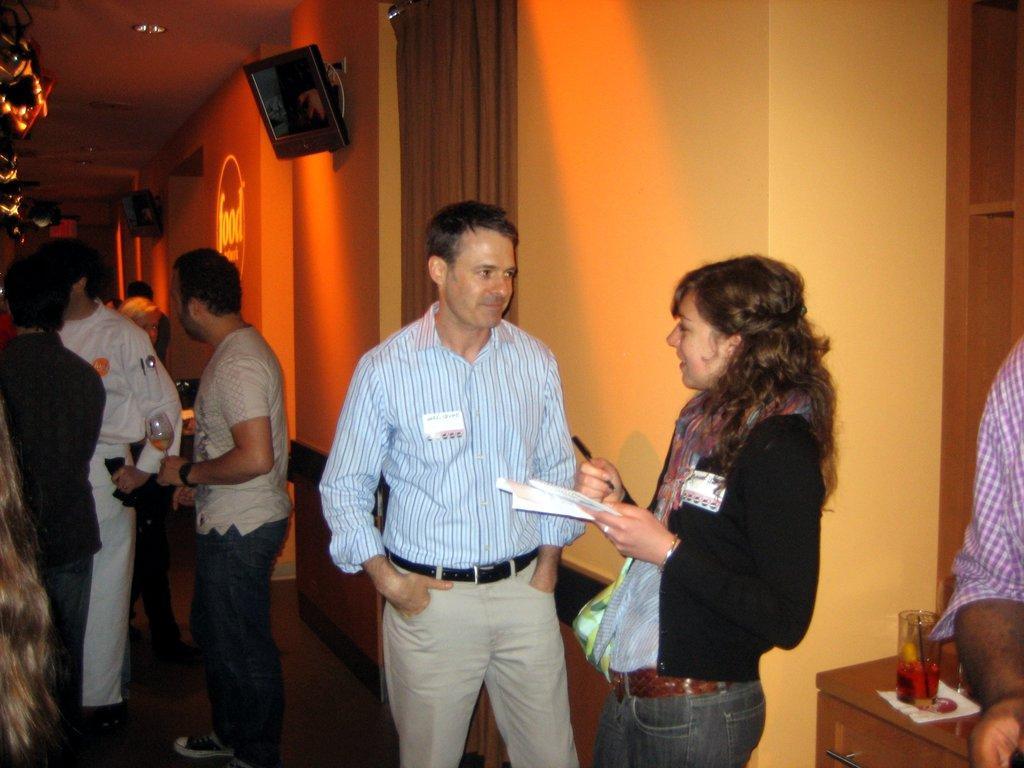Could you give a brief overview of what you see in this image? In this image, there are a few people. We can see the ground and a table with a glass on the right. We can see the wall with some text and objects like screens. We can also see the roof with some lights. We can see some objects on the left. 